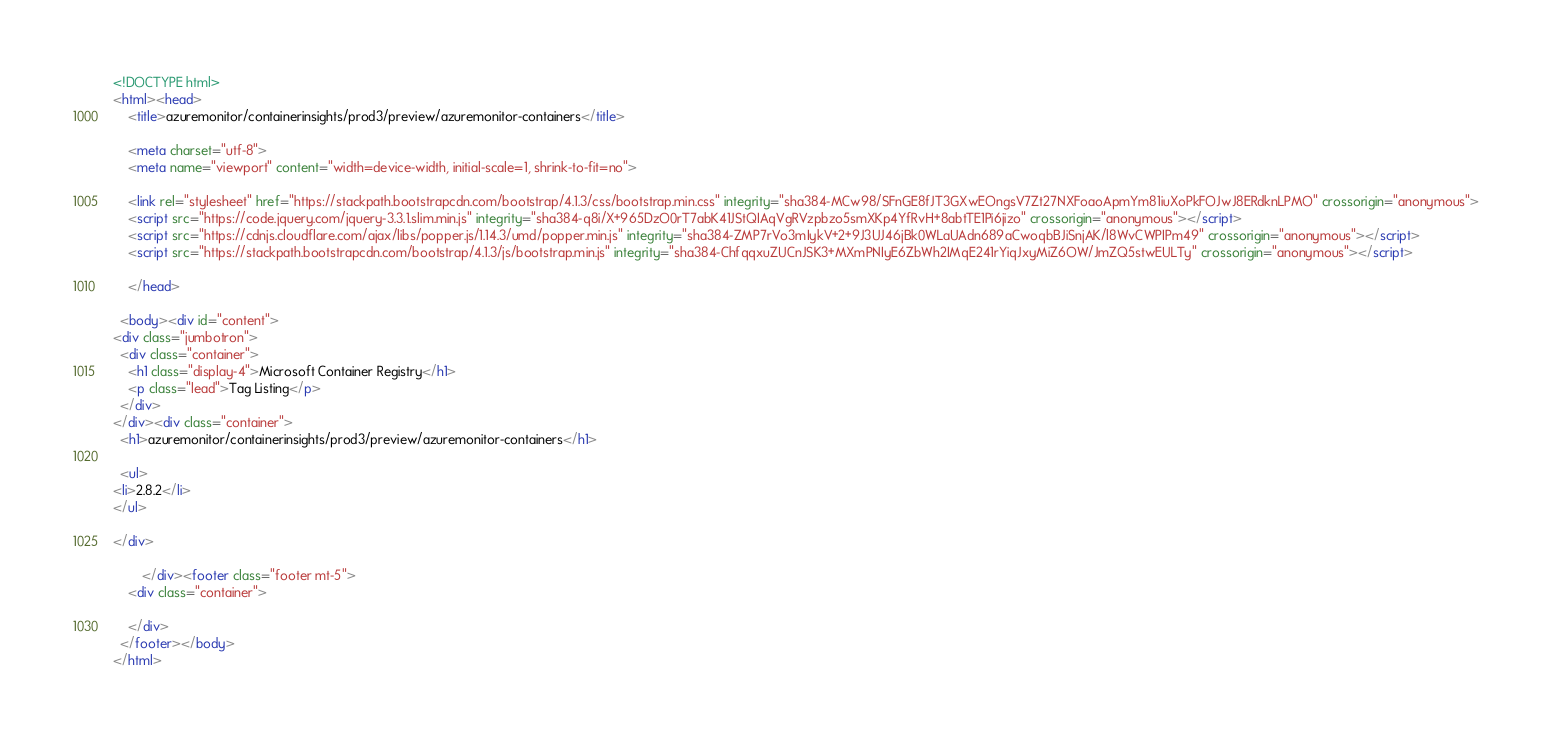<code> <loc_0><loc_0><loc_500><loc_500><_HTML_><!DOCTYPE html>
<html><head>
    <title>azuremonitor/containerinsights/prod3/preview/azuremonitor-containers</title>
    
    <meta charset="utf-8">
    <meta name="viewport" content="width=device-width, initial-scale=1, shrink-to-fit=no">
  
    <link rel="stylesheet" href="https://stackpath.bootstrapcdn.com/bootstrap/4.1.3/css/bootstrap.min.css" integrity="sha384-MCw98/SFnGE8fJT3GXwEOngsV7Zt27NXFoaoApmYm81iuXoPkFOJwJ8ERdknLPMO" crossorigin="anonymous">
    <script src="https://code.jquery.com/jquery-3.3.1.slim.min.js" integrity="sha384-q8i/X+965DzO0rT7abK41JStQIAqVgRVzpbzo5smXKp4YfRvH+8abtTE1Pi6jizo" crossorigin="anonymous"></script>
    <script src="https://cdnjs.cloudflare.com/ajax/libs/popper.js/1.14.3/umd/popper.min.js" integrity="sha384-ZMP7rVo3mIykV+2+9J3UJ46jBk0WLaUAdn689aCwoqbBJiSnjAK/l8WvCWPIPm49" crossorigin="anonymous"></script>
    <script src="https://stackpath.bootstrapcdn.com/bootstrap/4.1.3/js/bootstrap.min.js" integrity="sha384-ChfqqxuZUCnJSK3+MXmPNIyE6ZbWh2IMqE241rYiqJxyMiZ6OW/JmZQ5stwEULTy" crossorigin="anonymous"></script>
  
    </head>

  <body><div id="content">
<div class="jumbotron">
  <div class="container">
    <h1 class="display-4">Microsoft Container Registry</h1>
    <p class="lead">Tag Listing</p>    
  </div>
</div><div class="container">
  <h1>azuremonitor/containerinsights/prod3/preview/azuremonitor-containers</h1>

  <ul>
<li>2.8.2</li>
</ul>

</div>

        </div><footer class="footer mt-5">
    <div class="container">
      
    </div>
  </footer></body>
</html>
</code> 